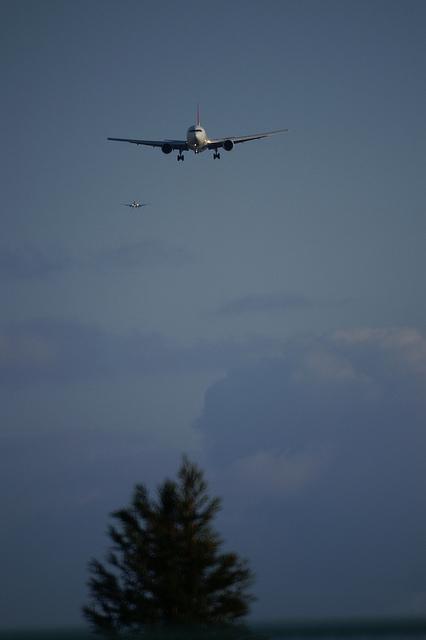How old is this picture?
Keep it brief. New. Is it kite day?
Write a very short answer. No. Are the planes coming or going?
Be succinct. Coming. Do the planes look like they're getting ready to land?
Short answer required. Yes. What is the plane doing?
Concise answer only. Flying. Is this a commercial aircraft?
Be succinct. Yes. What is the people flying?
Write a very short answer. Airplane. What year was this picture taken?
Be succinct. 2016. Could those trees be tropical?
Be succinct. No. Is this a Christmas tree?
Write a very short answer. No. Is the plane taking off or landing?
Give a very brief answer. Landing. Is there a lone bird?
Quick response, please. No. Is there a body of water here?
Write a very short answer. No. Are there clouds visible?
Short answer required. Yes. How high is the airplane flying?
Give a very brief answer. 10000 feet. Is this plane landing?
Answer briefly. Yes. Is it day or night?
Write a very short answer. Day. Is the plane taking off?
Write a very short answer. No. How many vehicles are in this picture?
Answer briefly. 1. Where are the people?
Give a very brief answer. In plane. Is this a jet?
Concise answer only. Yes. Is this plane taking off or landing?
Give a very brief answer. Landing. Are the planes flying?
Short answer required. Yes. How high is the plane?
Short answer required. 2000 feet. Is someone sitting on the ground?
Quick response, please. No. What is flying in the air?
Answer briefly. Airplane. Where is this picture at?
Concise answer only. Outside. Is this a rescue mission?
Be succinct. No. Are there clouds in the photo?
Answer briefly. Yes. What is in the sky?
Short answer required. Plane. Which planet is farthest away?
Answer briefly. Lower one. 